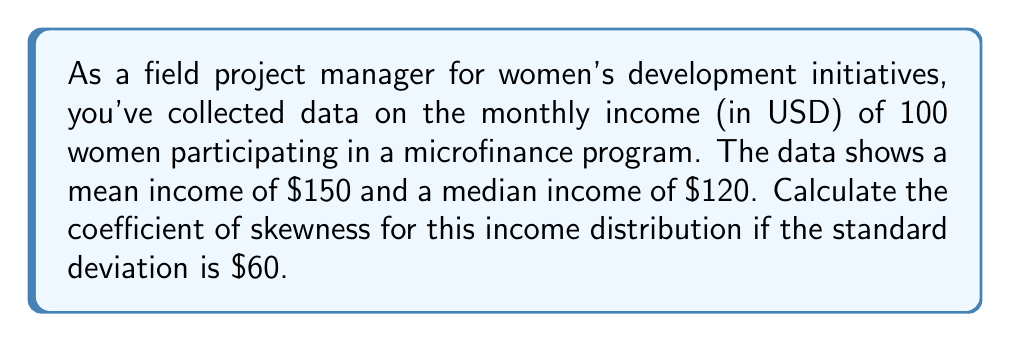What is the answer to this math problem? To calculate the coefficient of skewness, we'll use Pearson's second coefficient of skewness, which is suitable when we have the mean, median, and standard deviation.

The formula for Pearson's second coefficient of skewness is:

$$ \text{Skewness} = \frac{3(\text{Mean} - \text{Median})}{\text{Standard Deviation}} $$

Let's plug in the values we know:
- Mean ($\mu$) = $150
- Median = $120
- Standard Deviation ($\sigma$) = $60

$$ \text{Skewness} = \frac{3($150 - $120)}{$60} $$

$$ = \frac{3($30)}{$60} $$

$$ = \frac{$90}{$60} $$

$$ = 1.5 $$

The positive skewness coefficient indicates that the distribution is right-skewed, meaning there are some higher-income outliers pulling the mean above the median. This is common in income distributions, where a few high earners can significantly affect the mean.

In the context of the women's development initiative, this suggests that while most participants have incomes closer to or below the median of $120, there are some women who have achieved notably higher incomes, possibly due to the success of the microfinance program.
Answer: 1.5 